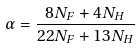Convert formula to latex. <formula><loc_0><loc_0><loc_500><loc_500>\alpha = \frac { 8 N _ { F } + 4 N _ { H } } { 2 2 N _ { F } + 1 3 N _ { H } }</formula> 